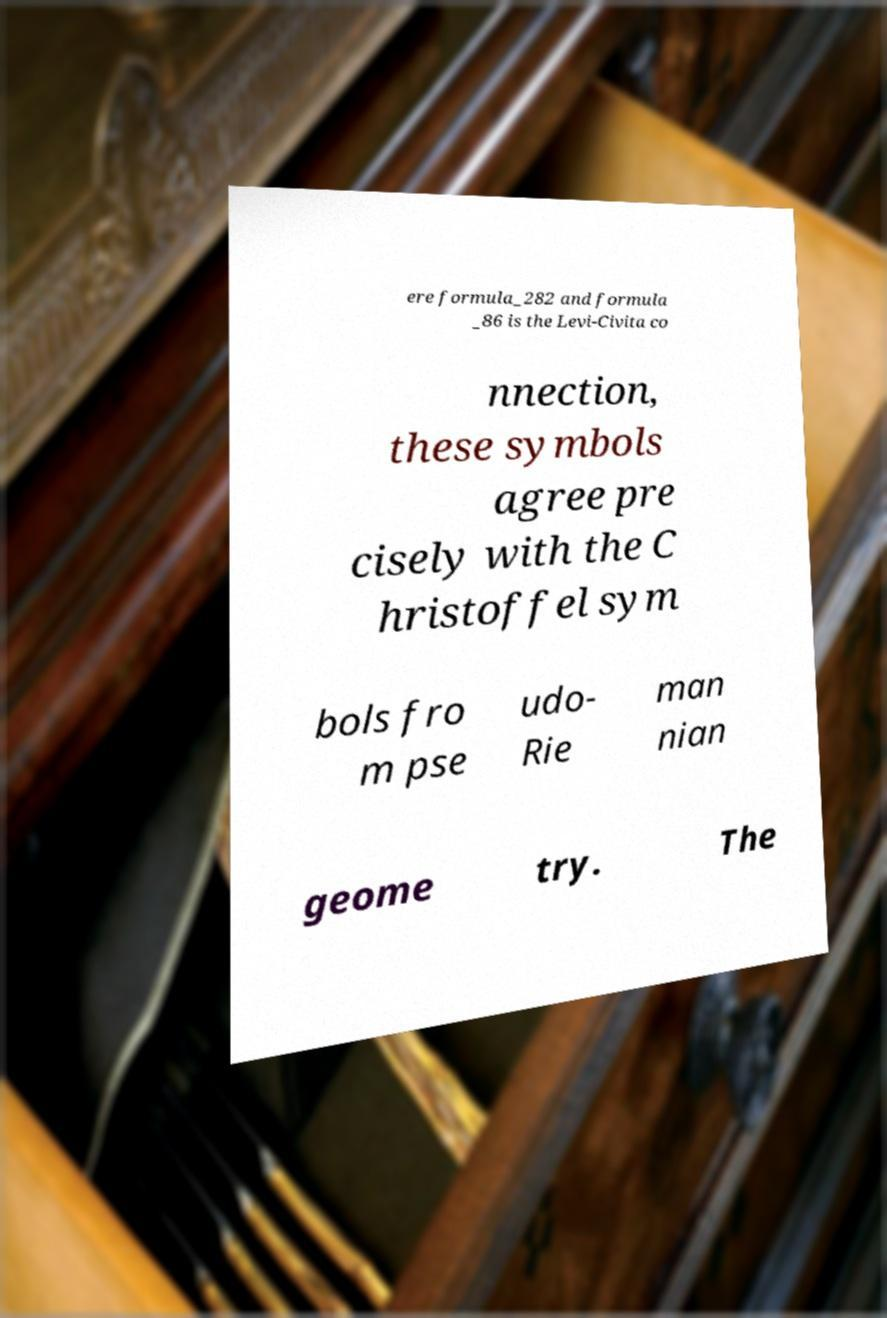What messages or text are displayed in this image? I need them in a readable, typed format. ere formula_282 and formula _86 is the Levi-Civita co nnection, these symbols agree pre cisely with the C hristoffel sym bols fro m pse udo- Rie man nian geome try. The 